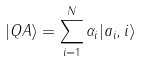<formula> <loc_0><loc_0><loc_500><loc_500>| Q A \rangle = \sum _ { i = 1 } ^ { N } \alpha _ { i } | a _ { i } , i \rangle</formula> 